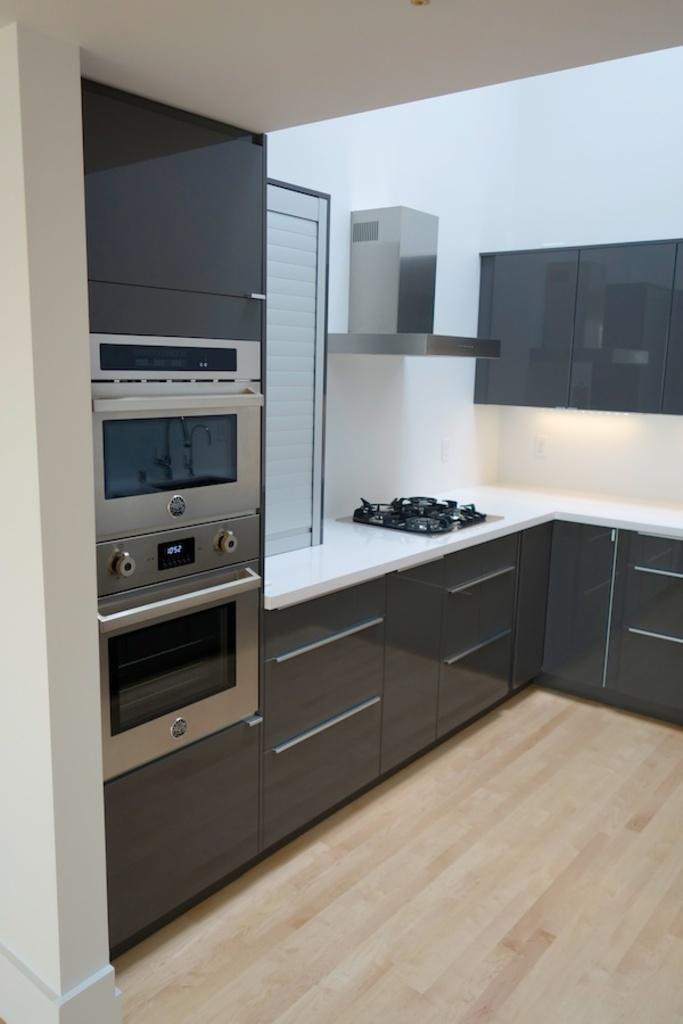What type of room is depicted in the image? The image is an inside picture of a room. What is the main feature of the room? There is a kitchen platform in the room. What cooking appliances are present in the room? There is a stove and an oven in the room. What is used for ventilation in the room? There is a chimney in the room for ventilation. What storage options are available in the room? There are cupboards in the room for storage. What type of flooring is present in the room? The flooring at the bottom of the image is wooden. What learning material is placed on the kitchen platform in the image? There is no learning material present on the kitchen platform in the image. Is there a lock on the oven in the image? The image does not show a lock on the oven. 